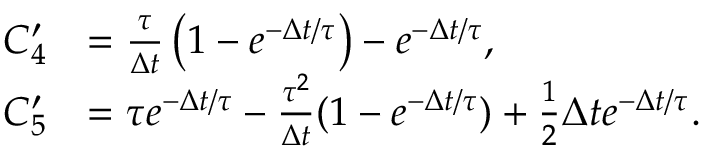<formula> <loc_0><loc_0><loc_500><loc_500>\begin{array} { r l } { C _ { 4 } ^ { \prime } } & { = \frac { \tau } { \Delta t } \left ( 1 - e ^ { - \Delta t / \tau } \right ) - e ^ { - \Delta t / \tau } , } \\ { C _ { 5 } ^ { \prime } } & { = \tau e ^ { - \Delta t / \tau } - \frac { \tau ^ { 2 } } { \Delta t } ( 1 - e ^ { - \Delta t / \tau } ) + \frac { 1 } { 2 } \Delta t e ^ { - \Delta t / \tau } . } \end{array}</formula> 